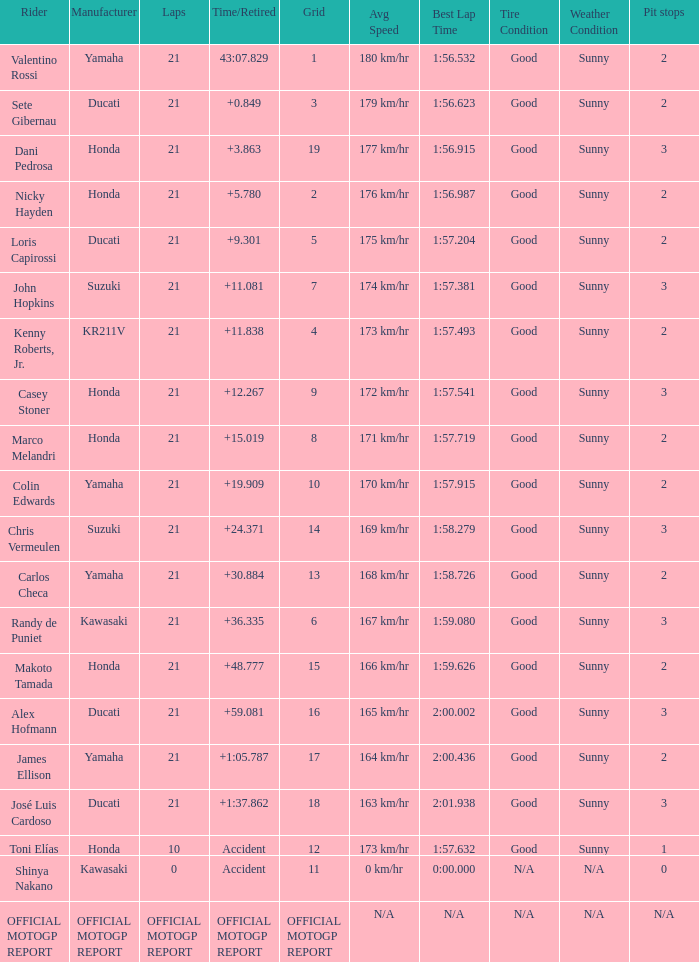Which rider had a time/retired od +19.909? Colin Edwards. 